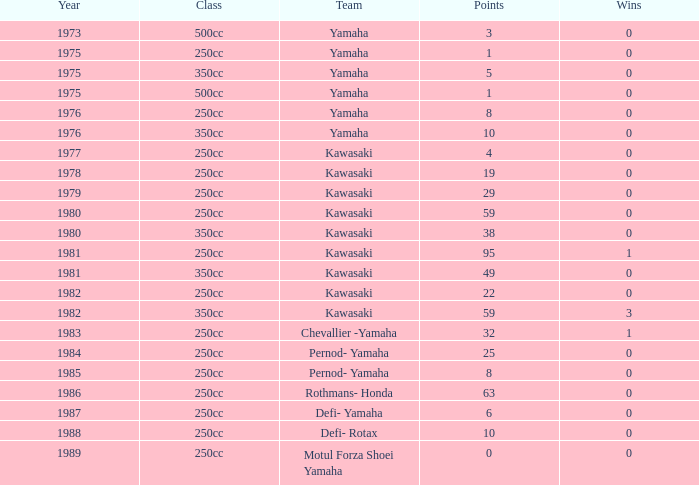In a 250cc class, a year preceding 1978, how many points did yamaha as a team have, and where the number of wins was above 0? 0.0. 